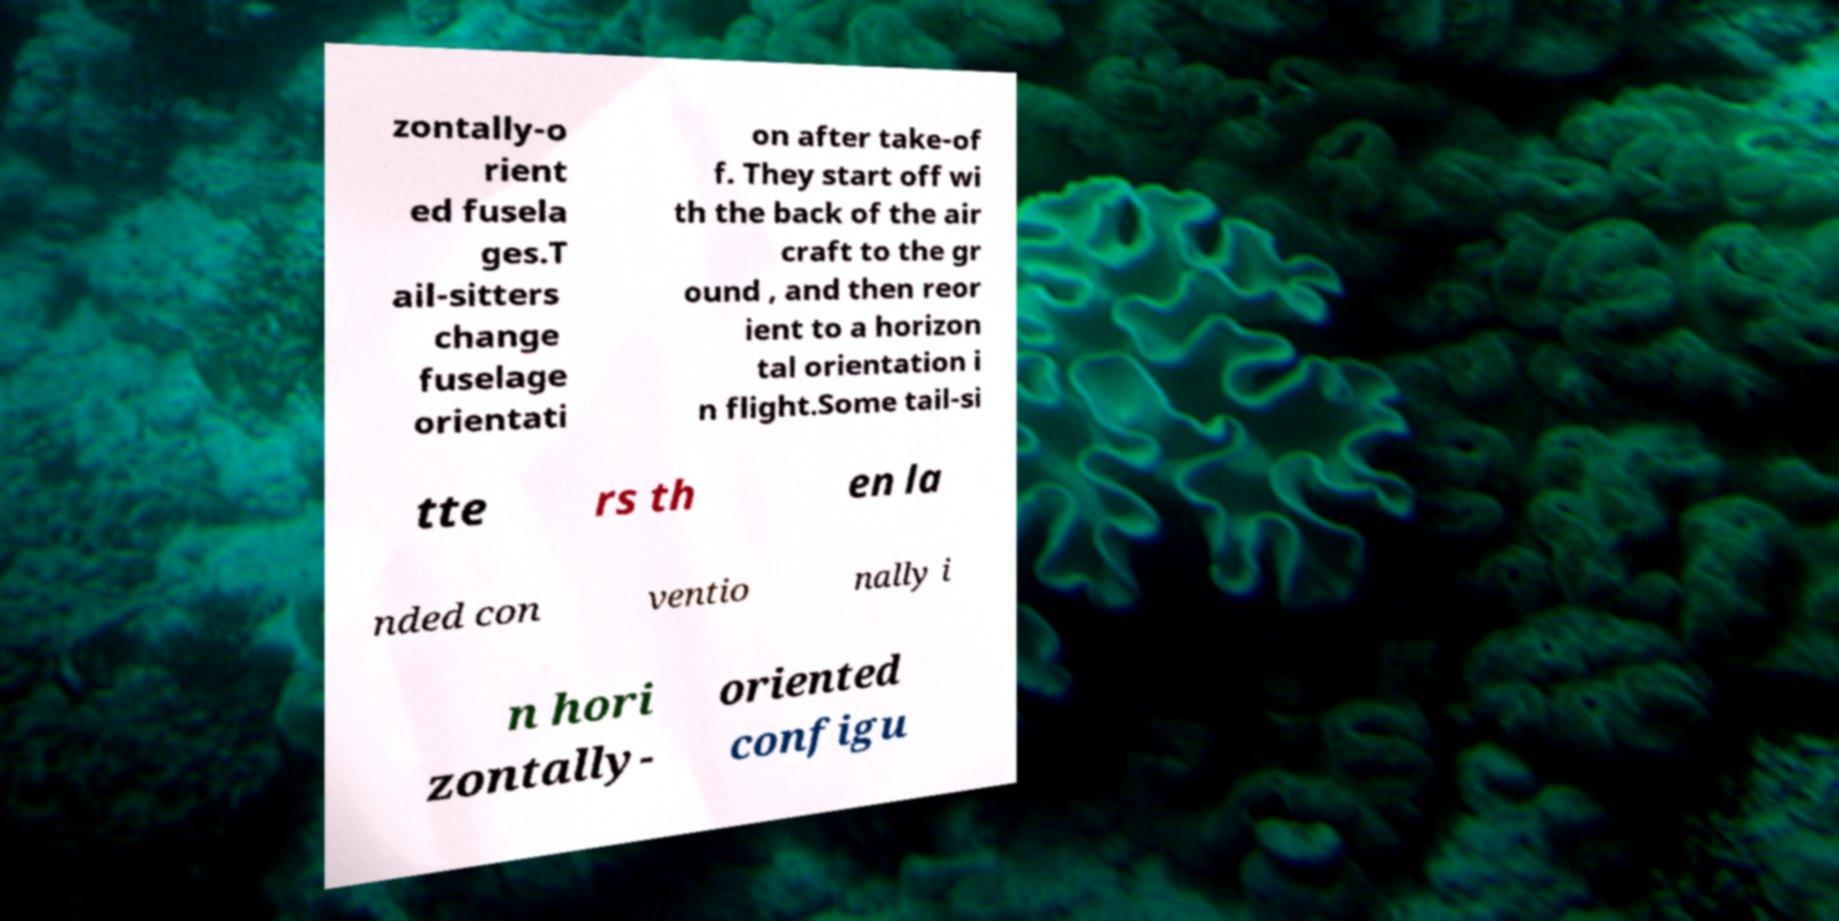Please read and relay the text visible in this image. What does it say? zontally-o rient ed fusela ges.T ail-sitters change fuselage orientati on after take-of f. They start off wi th the back of the air craft to the gr ound , and then reor ient to a horizon tal orientation i n flight.Some tail-si tte rs th en la nded con ventio nally i n hori zontally- oriented configu 